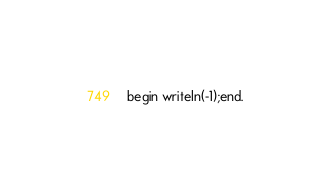Convert code to text. <code><loc_0><loc_0><loc_500><loc_500><_Pascal_>begin writeln(-1);end.</code> 